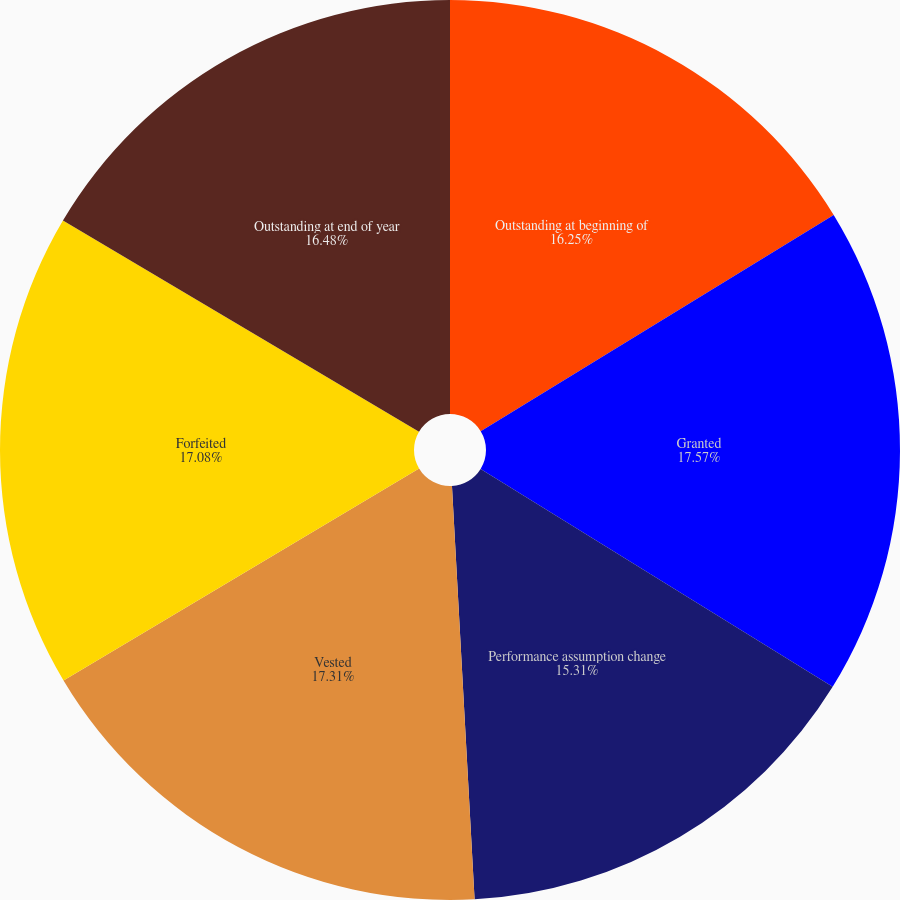Convert chart. <chart><loc_0><loc_0><loc_500><loc_500><pie_chart><fcel>Outstanding at beginning of<fcel>Granted<fcel>Performance assumption change<fcel>Vested<fcel>Forfeited<fcel>Outstanding at end of year<nl><fcel>16.25%<fcel>17.57%<fcel>15.31%<fcel>17.31%<fcel>17.08%<fcel>16.48%<nl></chart> 